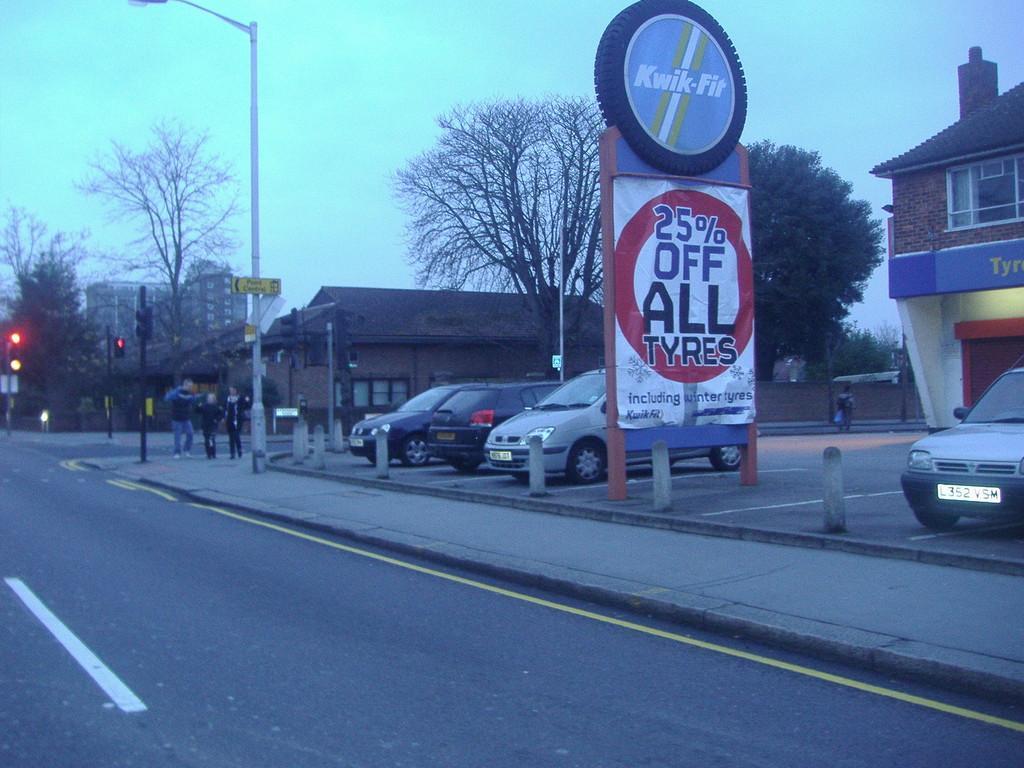Could you give a brief overview of what you see in this image? In this image we can see cars and there is a road. There are people. We can see poles and there are traffic lights. There are boards. In the background there are trees, buildings and sky. 